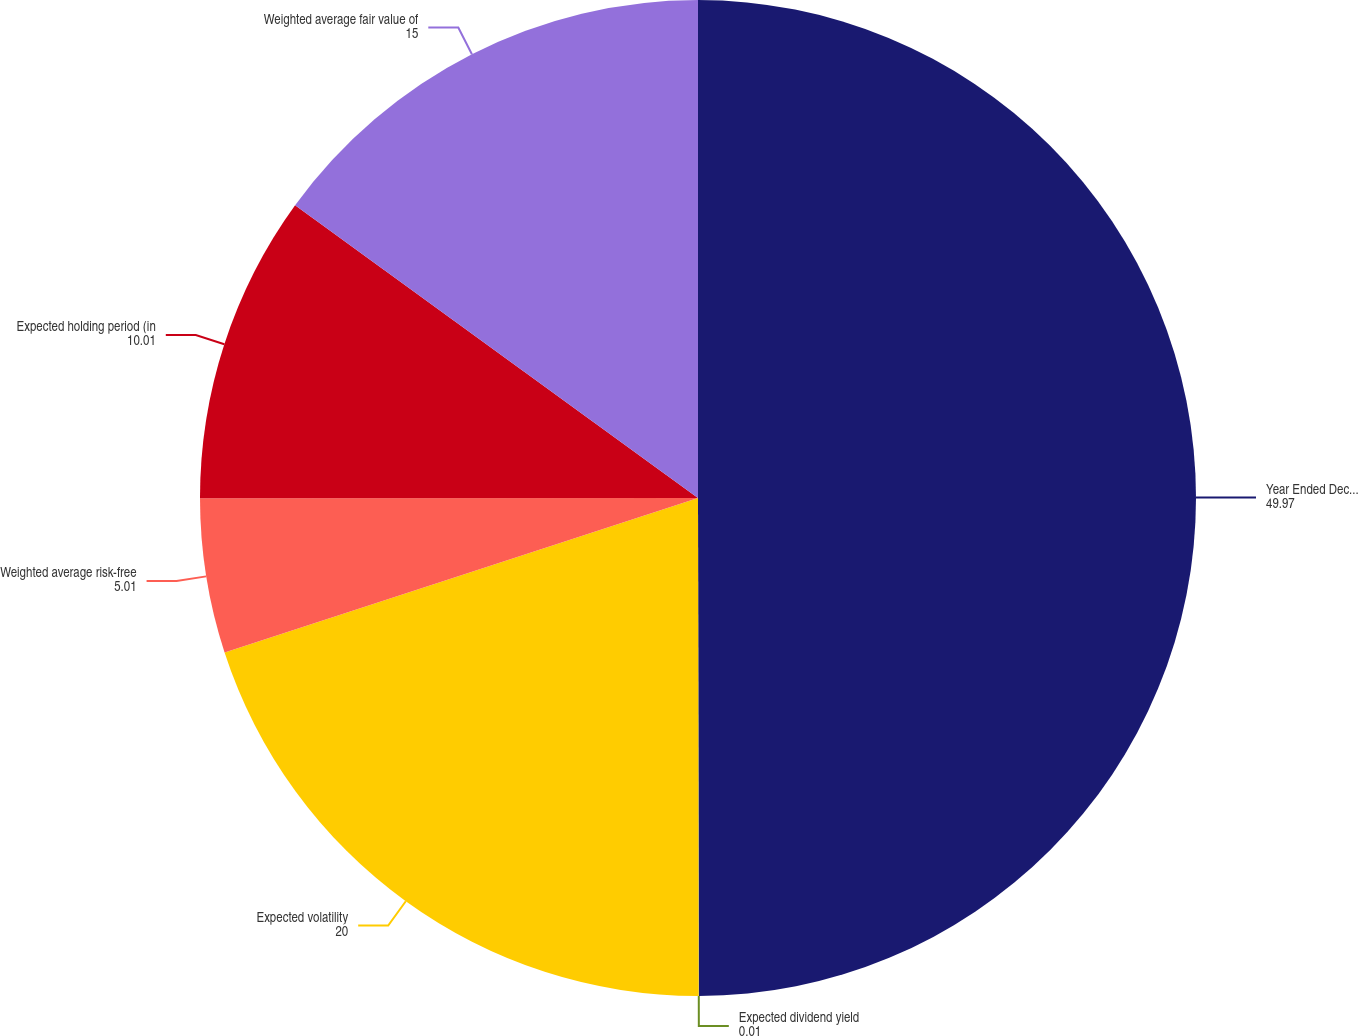Convert chart. <chart><loc_0><loc_0><loc_500><loc_500><pie_chart><fcel>Year Ended December 31<fcel>Expected dividend yield<fcel>Expected volatility<fcel>Weighted average risk-free<fcel>Expected holding period (in<fcel>Weighted average fair value of<nl><fcel>49.97%<fcel>0.01%<fcel>20.0%<fcel>5.01%<fcel>10.01%<fcel>15.0%<nl></chart> 